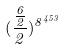Convert formula to latex. <formula><loc_0><loc_0><loc_500><loc_500>( \frac { \frac { 6 } { 2 } } { 2 } ) ^ { 8 ^ { 4 5 3 } }</formula> 